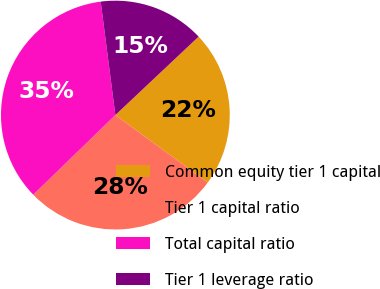<chart> <loc_0><loc_0><loc_500><loc_500><pie_chart><fcel>Common equity tier 1 capital<fcel>Tier 1 capital ratio<fcel>Total capital ratio<fcel>Tier 1 leverage ratio<nl><fcel>22.07%<fcel>27.7%<fcel>35.21%<fcel>15.02%<nl></chart> 